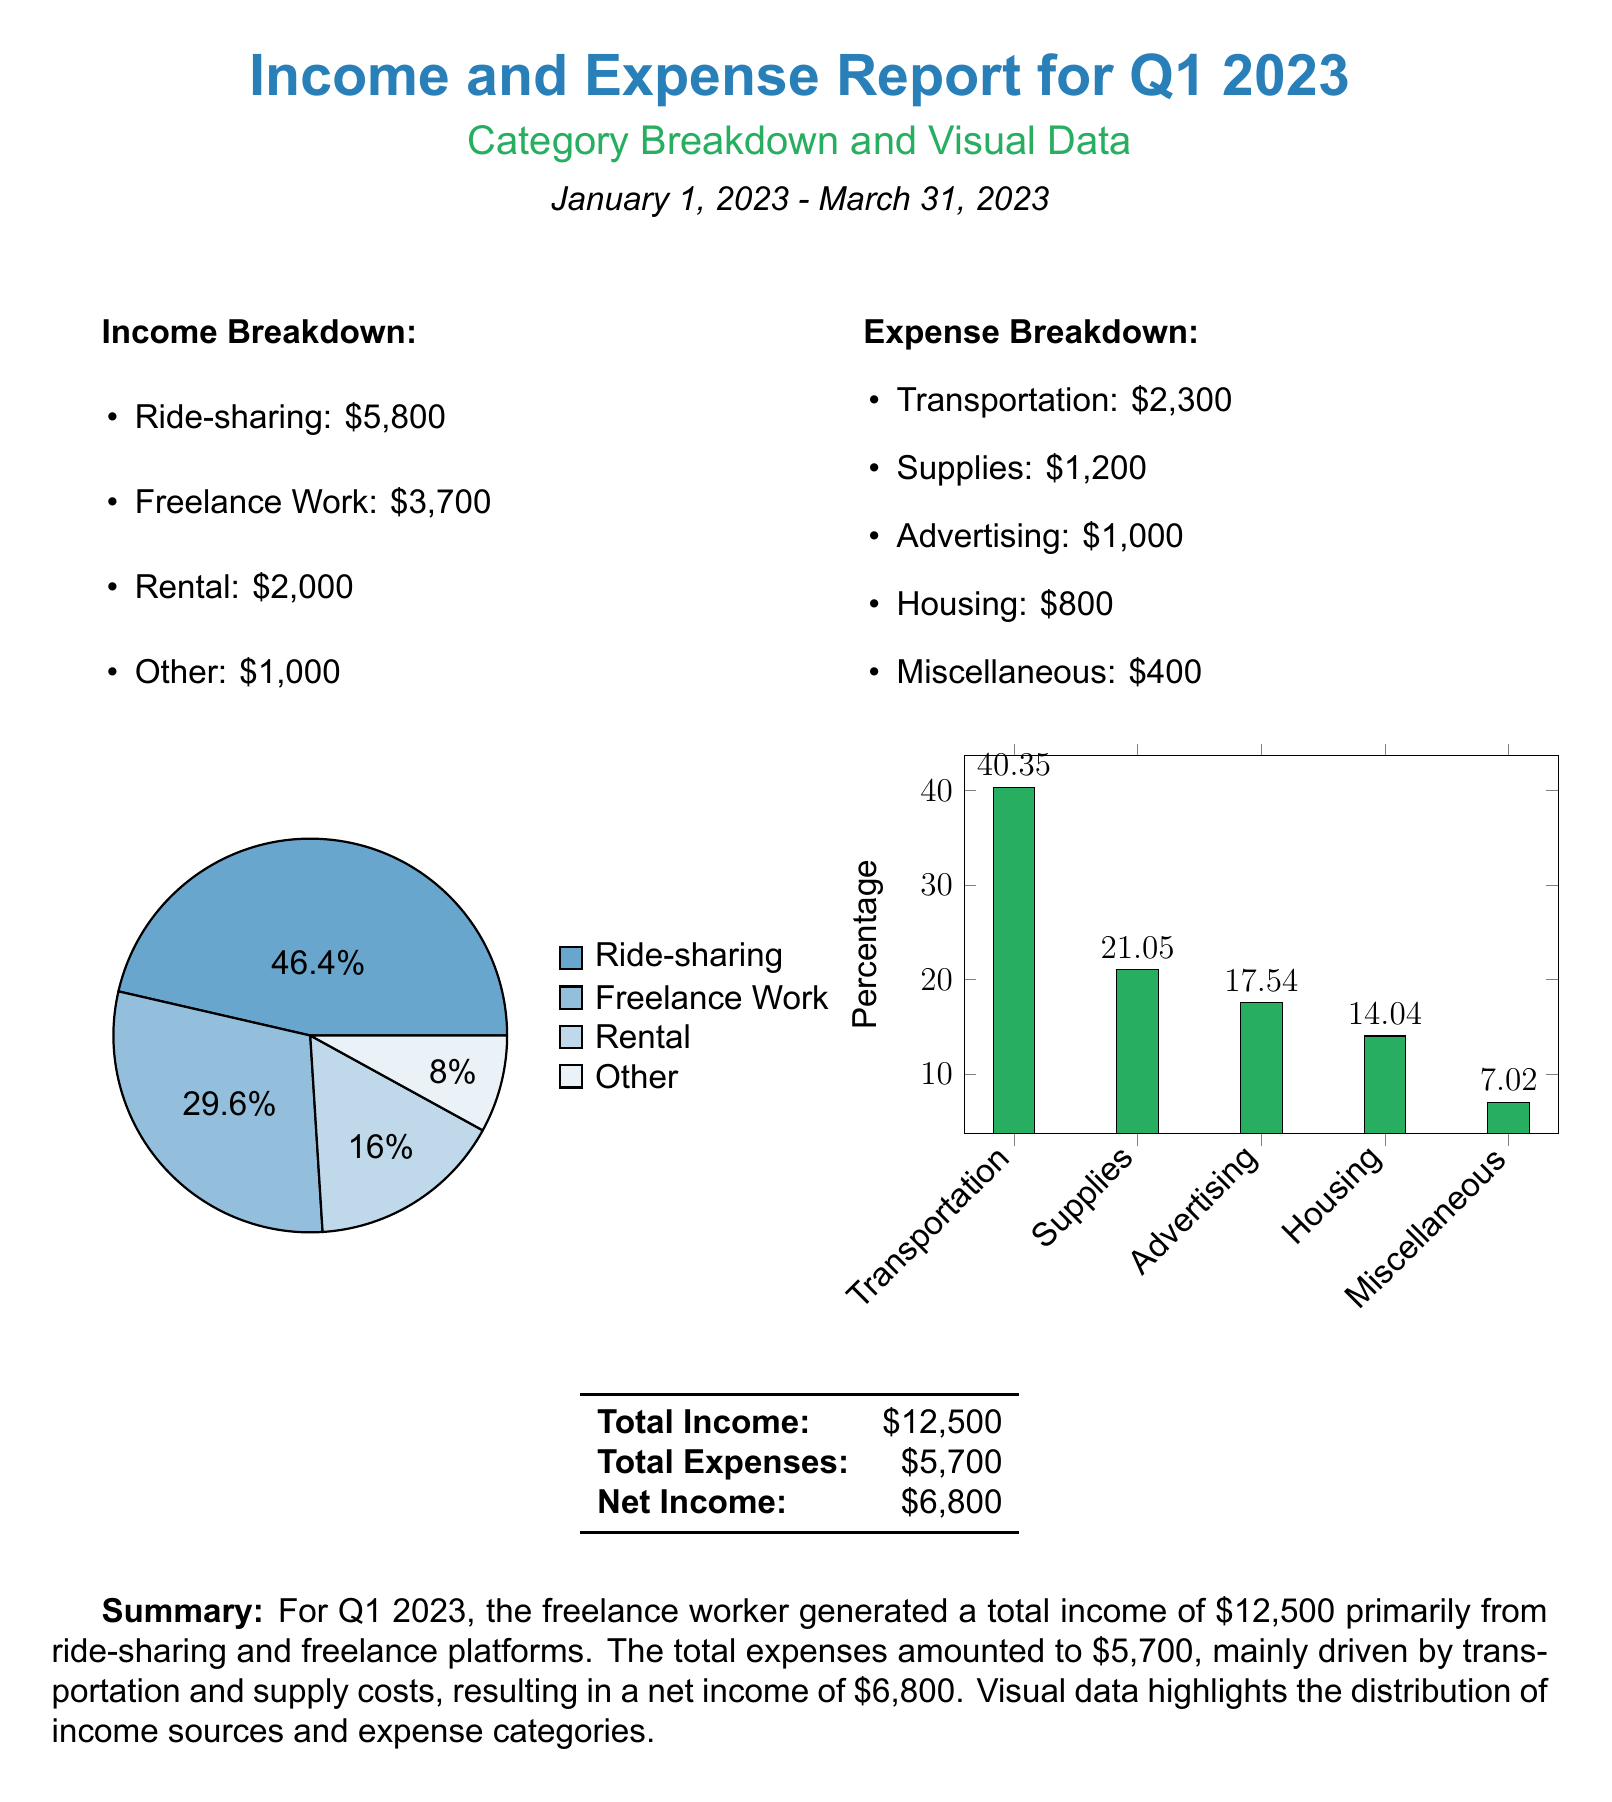what is the total income for Q1 2023? The total income is explicitly stated in the document as \$12,500.
Answer: \$12,500 how much was earned from ride-sharing? The document specifies that the income from ride-sharing is \$5,800.
Answer: \$5,800 what is the expense for transportation? The document lists the expense for transportation as \$2,300.
Answer: \$2,300 what is the net income for Q1 2023? The document calculates net income as total income minus total expenses, which results in \$6,800.
Answer: \$6,800 which category had the highest income percentage? The pie chart indicates that ride-sharing has the highest income percentage at 46.4%.
Answer: Ride-sharing how much did the freelance work contribute to income? The document states that freelance work contributed \$3,700 to the total income.
Answer: \$3,700 which expense category has the lowest percentage? The bar chart shows that Miscellaneous has the lowest percentage at 7.02%.
Answer: Miscellaneous what is the total expense amount for Q1 2023? The document states that the total expenses amount to \$5,700.
Answer: \$5,700 which category accounted for the largest expense? The bar chart indicates that Transportation accounted for the largest expense at 40.35%.
Answer: Transportation 